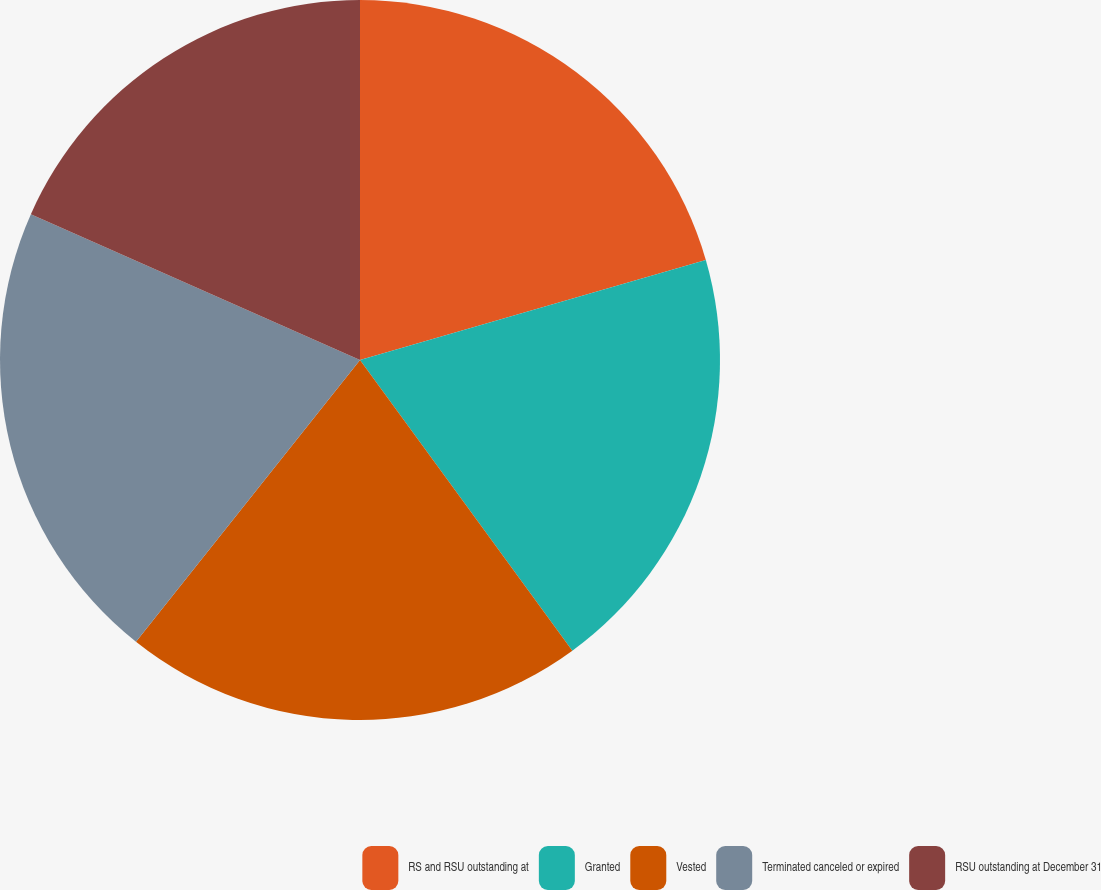Convert chart. <chart><loc_0><loc_0><loc_500><loc_500><pie_chart><fcel>RS and RSU outstanding at<fcel>Granted<fcel>Vested<fcel>Terminated canceled or expired<fcel>RSU outstanding at December 31<nl><fcel>20.52%<fcel>19.44%<fcel>20.73%<fcel>20.95%<fcel>18.36%<nl></chart> 